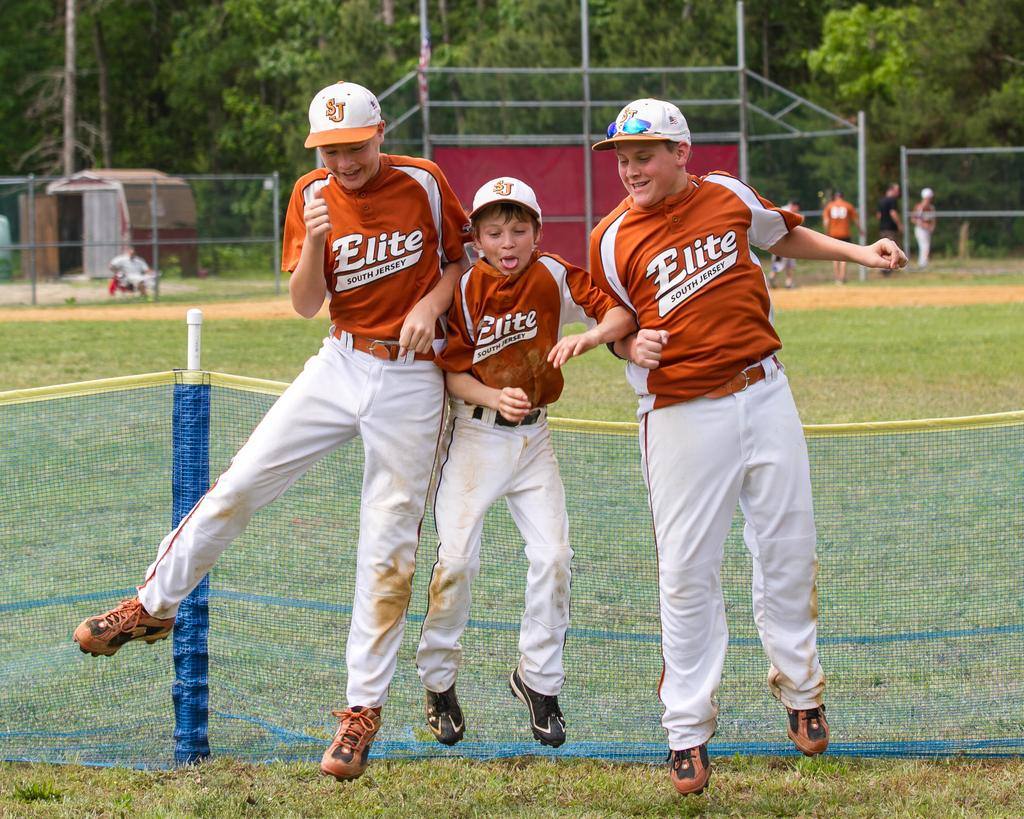<image>
Write a terse but informative summary of the picture. Three boys that play on the Elite baseball team goof around near the field. 